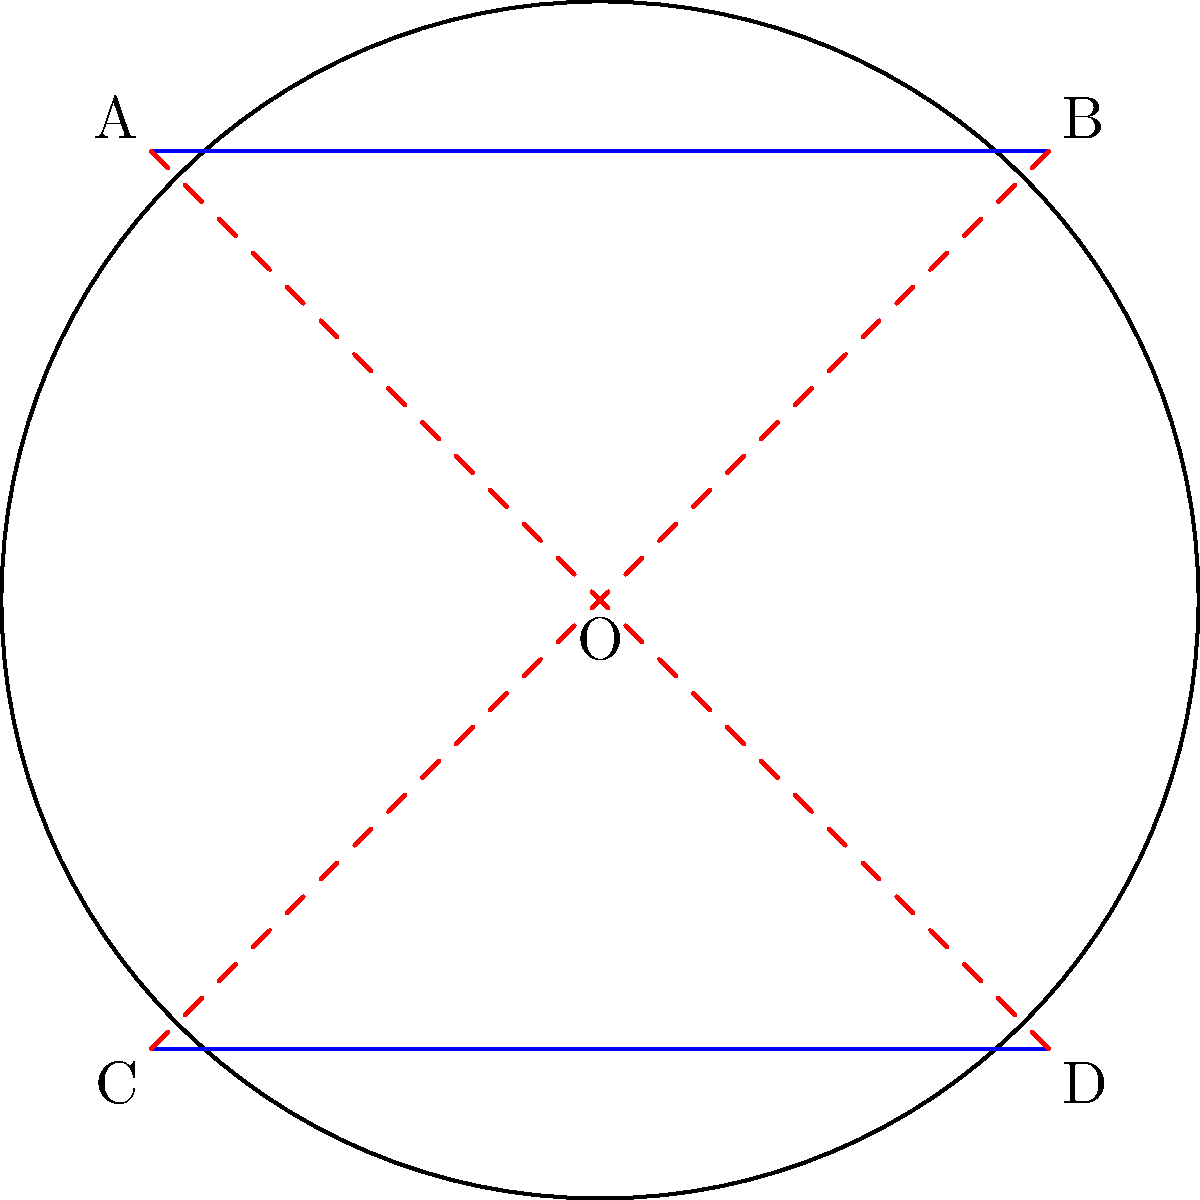In elliptic geometry, parallel lines behave differently than in Euclidean geometry. Consider two "parallel" lines AB and CD on the surface of a sphere, as shown in the diagram. How do these lines relate to sound reflection in a spherical recording studio, and at what point(s) do they intersect? To understand this concept and its relation to sound reflection, let's follow these steps:

1. In elliptic geometry, which models the surface of a sphere, "parallel" lines are great circles that intersect at two antipodal points.

2. In the diagram, lines AB and CD are represented as blue arcs on the circle, which is a 2D projection of a sphere.

3. These lines intersect at two points: the center O (representing both the "north" and "south" poles of the sphere) and the point at infinity (representing the opposite side of the sphere).

4. In a spherical recording studio:
   a) Sound waves would travel along these great circles.
   b) The intersection points represent locations where sound waves from different directions converge.

5. This behavior is similar to how parallel light rays focus at two points when reflected off a spherical mirror:
   a) One focal point is between the center and the surface.
   b) The other focal point is on the opposite side of the sphere.

6. For sound engineering, this means:
   a) There would be two "hot spots" where sound intensifies.
   b) These spots would be antipodal (directly opposite) to each other on the sphere's surface.

7. The red dashed lines in the diagram represent the radii to the intersection points, illustrating how the parallel lines meet at the center and at infinity.

This non-Euclidean behavior of parallel lines in elliptic geometry has important implications for sound reflection and acoustics in spherical spaces.
Answer: Intersect at two antipodal points: center and infinity 